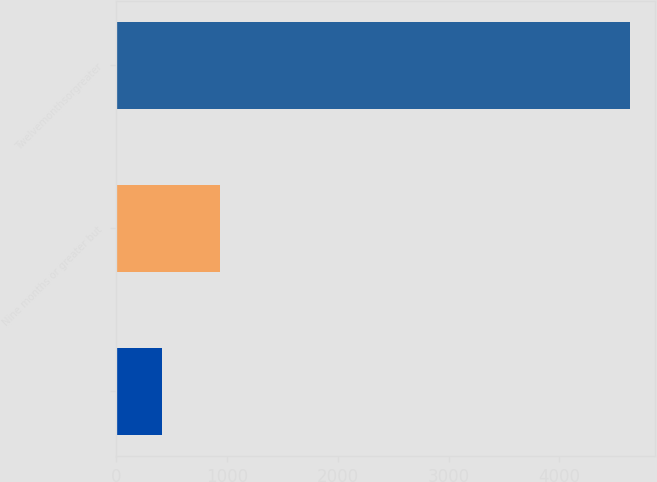Convert chart to OTSL. <chart><loc_0><loc_0><loc_500><loc_500><bar_chart><ecel><fcel>Nine months or greater but<fcel>Twelvemonthsorgreater<nl><fcel>415<fcel>937<fcel>4634<nl></chart> 